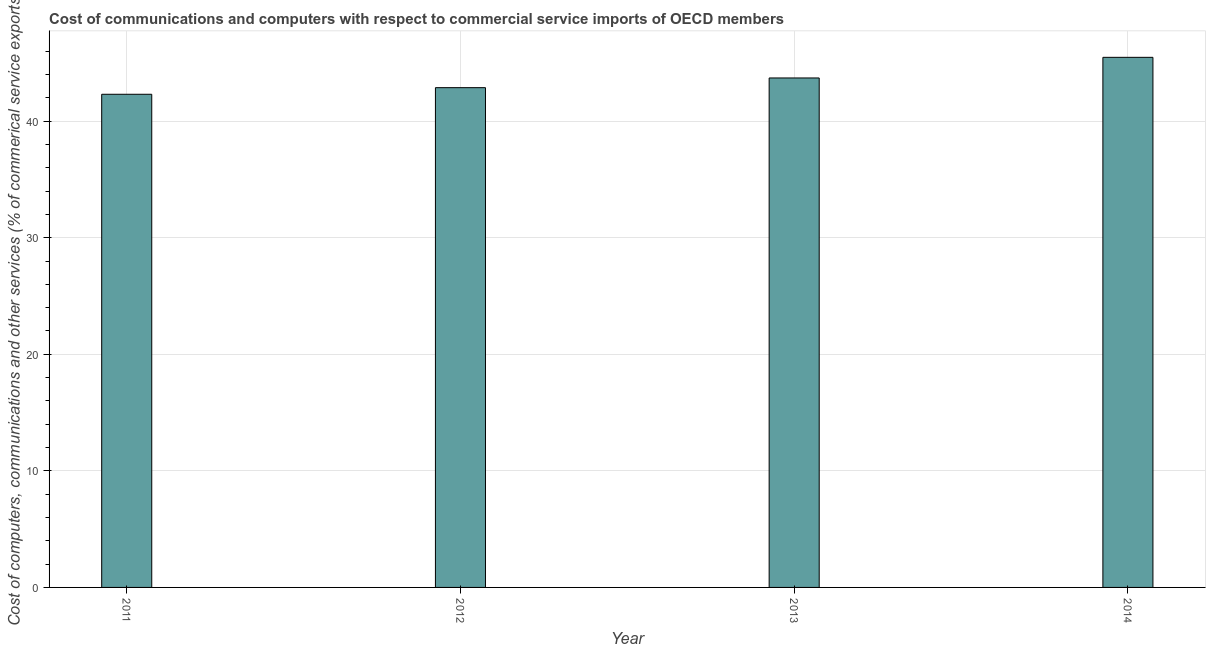Does the graph contain any zero values?
Your response must be concise. No. Does the graph contain grids?
Give a very brief answer. Yes. What is the title of the graph?
Offer a terse response. Cost of communications and computers with respect to commercial service imports of OECD members. What is the label or title of the X-axis?
Your response must be concise. Year. What is the label or title of the Y-axis?
Offer a terse response. Cost of computers, communications and other services (% of commerical service exports). What is the cost of communications in 2013?
Give a very brief answer. 43.7. Across all years, what is the maximum  computer and other services?
Keep it short and to the point. 45.47. Across all years, what is the minimum  computer and other services?
Give a very brief answer. 42.3. In which year was the cost of communications maximum?
Keep it short and to the point. 2014. In which year was the  computer and other services minimum?
Offer a terse response. 2011. What is the sum of the cost of communications?
Provide a short and direct response. 174.35. What is the difference between the cost of communications in 2012 and 2014?
Your answer should be compact. -2.6. What is the average  computer and other services per year?
Offer a very short reply. 43.59. What is the median cost of communications?
Your response must be concise. 43.29. What is the ratio of the  computer and other services in 2012 to that in 2014?
Your response must be concise. 0.94. Is the  computer and other services in 2011 less than that in 2012?
Your answer should be compact. Yes. Is the difference between the  computer and other services in 2011 and 2013 greater than the difference between any two years?
Make the answer very short. No. What is the difference between the highest and the second highest cost of communications?
Offer a very short reply. 1.77. What is the difference between the highest and the lowest cost of communications?
Ensure brevity in your answer.  3.17. In how many years, is the  computer and other services greater than the average  computer and other services taken over all years?
Keep it short and to the point. 2. How many bars are there?
Ensure brevity in your answer.  4. Are all the bars in the graph horizontal?
Provide a short and direct response. No. How many years are there in the graph?
Offer a very short reply. 4. What is the difference between two consecutive major ticks on the Y-axis?
Give a very brief answer. 10. What is the Cost of computers, communications and other services (% of commerical service exports) of 2011?
Provide a succinct answer. 42.3. What is the Cost of computers, communications and other services (% of commerical service exports) of 2012?
Ensure brevity in your answer.  42.87. What is the Cost of computers, communications and other services (% of commerical service exports) of 2013?
Ensure brevity in your answer.  43.7. What is the Cost of computers, communications and other services (% of commerical service exports) of 2014?
Your answer should be very brief. 45.47. What is the difference between the Cost of computers, communications and other services (% of commerical service exports) in 2011 and 2012?
Provide a short and direct response. -0.57. What is the difference between the Cost of computers, communications and other services (% of commerical service exports) in 2011 and 2013?
Your answer should be very brief. -1.4. What is the difference between the Cost of computers, communications and other services (% of commerical service exports) in 2011 and 2014?
Offer a terse response. -3.17. What is the difference between the Cost of computers, communications and other services (% of commerical service exports) in 2012 and 2013?
Your answer should be very brief. -0.83. What is the difference between the Cost of computers, communications and other services (% of commerical service exports) in 2012 and 2014?
Ensure brevity in your answer.  -2.6. What is the difference between the Cost of computers, communications and other services (% of commerical service exports) in 2013 and 2014?
Offer a terse response. -1.77. What is the ratio of the Cost of computers, communications and other services (% of commerical service exports) in 2011 to that in 2012?
Give a very brief answer. 0.99. What is the ratio of the Cost of computers, communications and other services (% of commerical service exports) in 2011 to that in 2013?
Offer a very short reply. 0.97. What is the ratio of the Cost of computers, communications and other services (% of commerical service exports) in 2012 to that in 2013?
Keep it short and to the point. 0.98. What is the ratio of the Cost of computers, communications and other services (% of commerical service exports) in 2012 to that in 2014?
Your response must be concise. 0.94. What is the ratio of the Cost of computers, communications and other services (% of commerical service exports) in 2013 to that in 2014?
Keep it short and to the point. 0.96. 